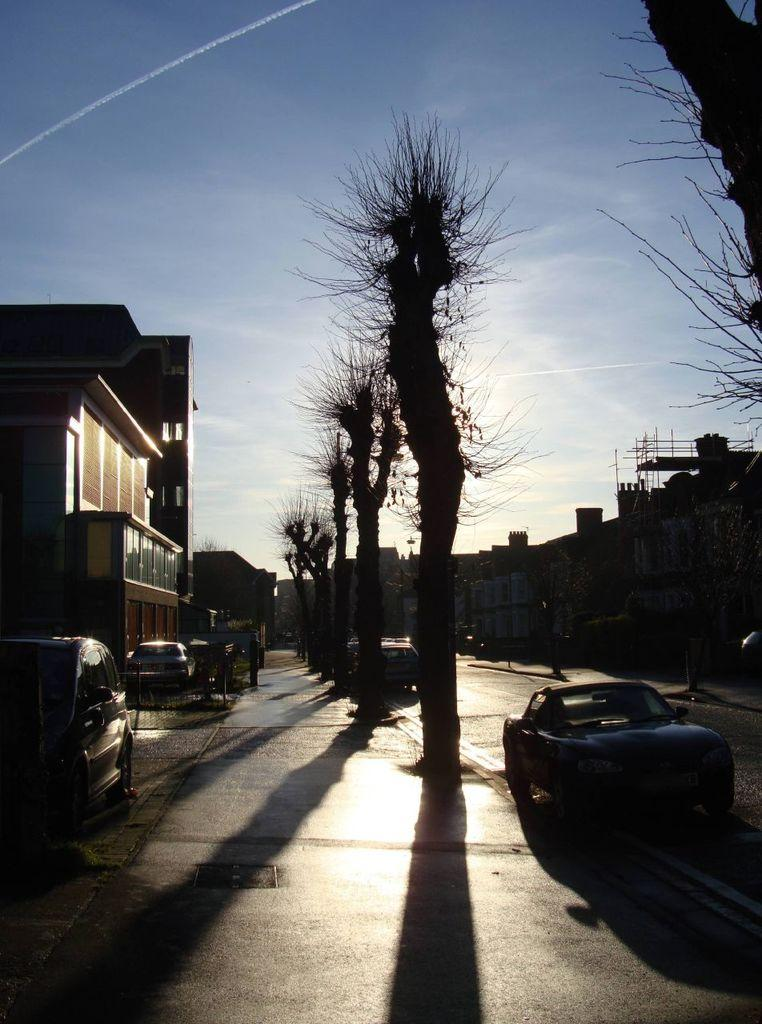What is the main subject of the image? The main subject of the image is a group of vehicles. What else can be seen in the image besides the vehicles? There are buildings and trees in the image. What is visible at the top of the image? The sky is visible at the top of the image. What type of wound can be seen on the title of the image? There is no wound or title present in the image. 